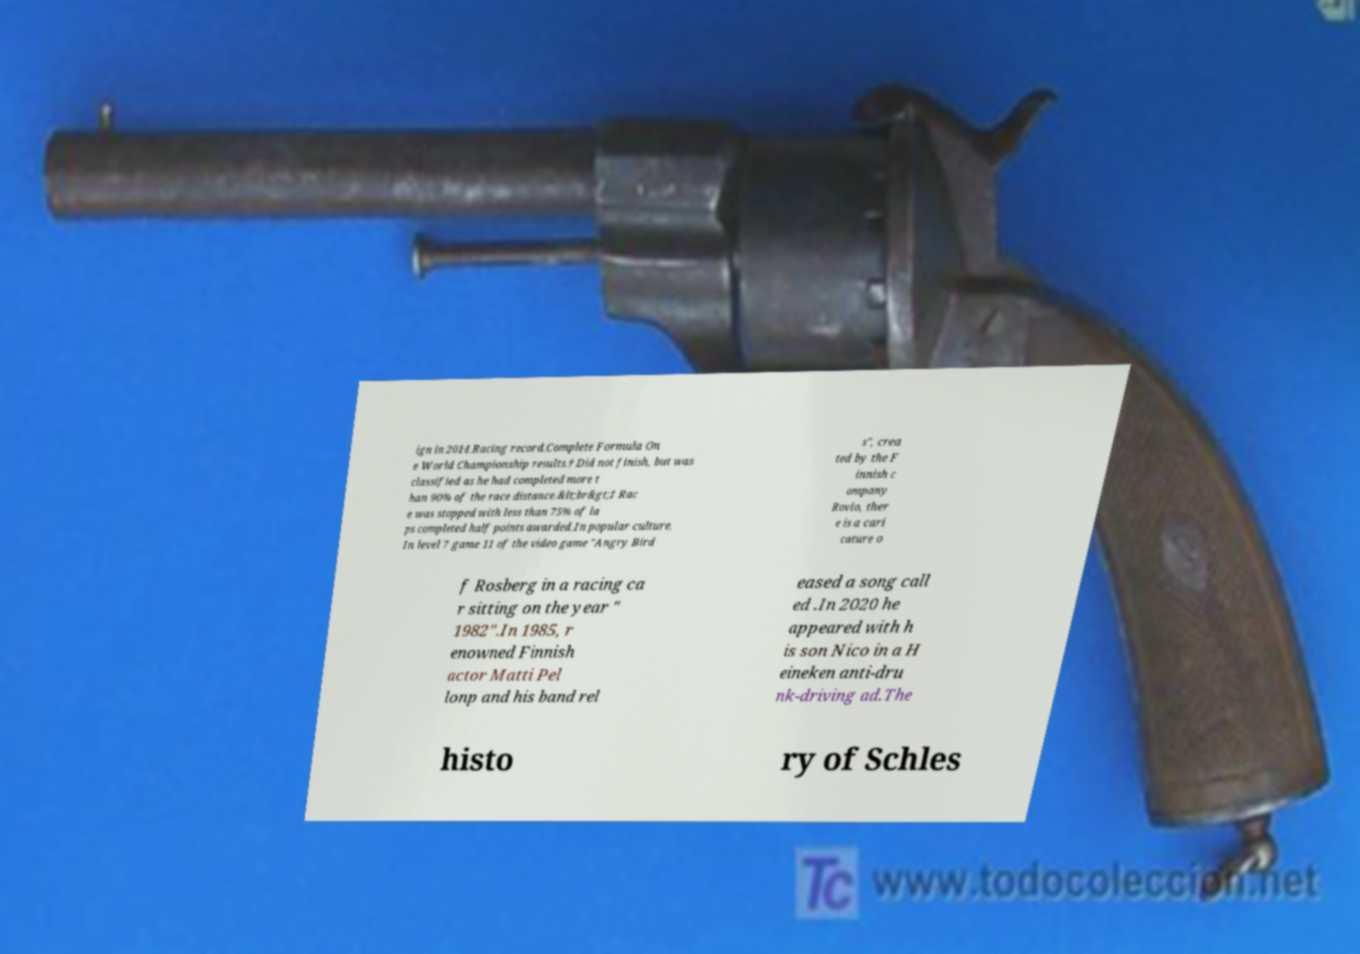Could you extract and type out the text from this image? ign in 2014.Racing record.Complete Formula On e World Championship results.† Did not finish, but was classified as he had completed more t han 90% of the race distance.&lt;br&gt;‡ Rac e was stopped with less than 75% of la ps completed half points awarded.In popular culture. In level 7 game 11 of the video game "Angry Bird s", crea ted by the F innish c ompany Rovio, ther e is a cari cature o f Rosberg in a racing ca r sitting on the year " 1982".In 1985, r enowned Finnish actor Matti Pel lonp and his band rel eased a song call ed .In 2020 he appeared with h is son Nico in a H eineken anti-dru nk-driving ad.The histo ry of Schles 